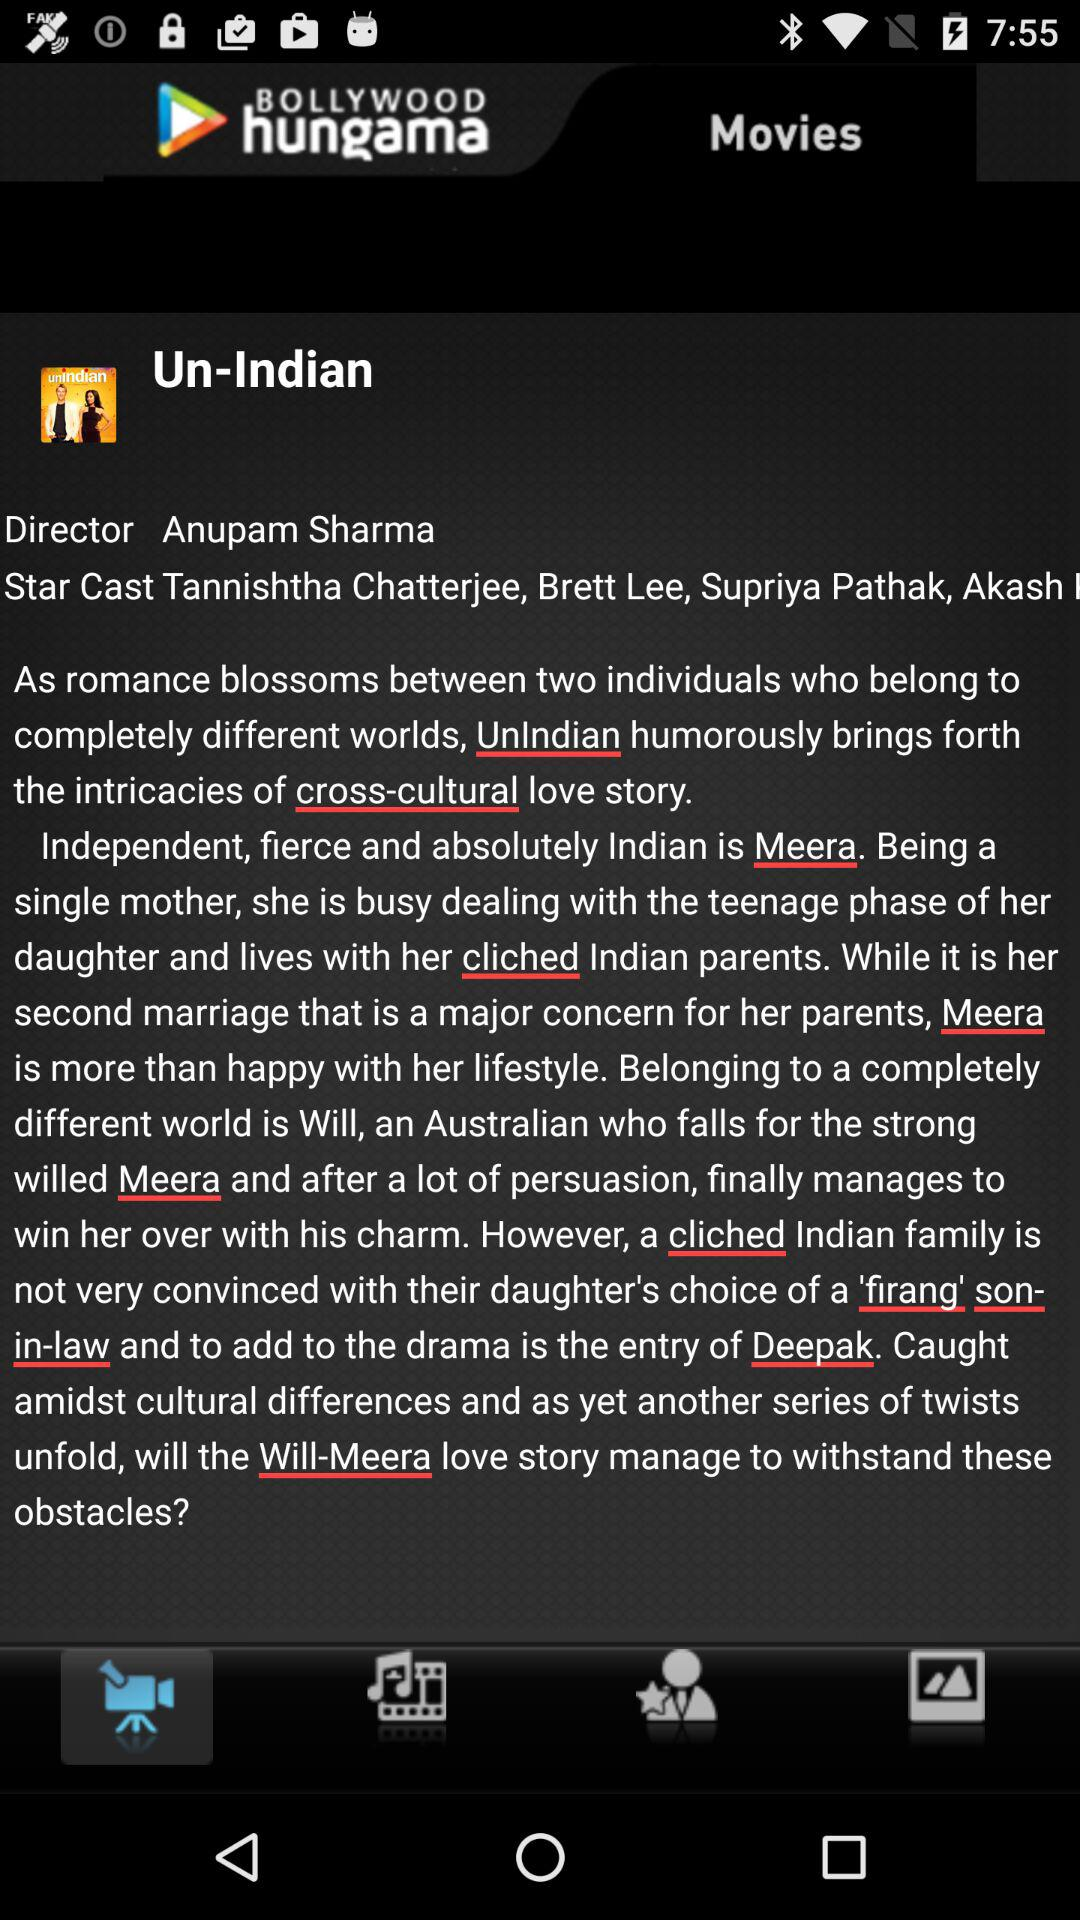What is the movie name? The movie name is "Un-Indian". 